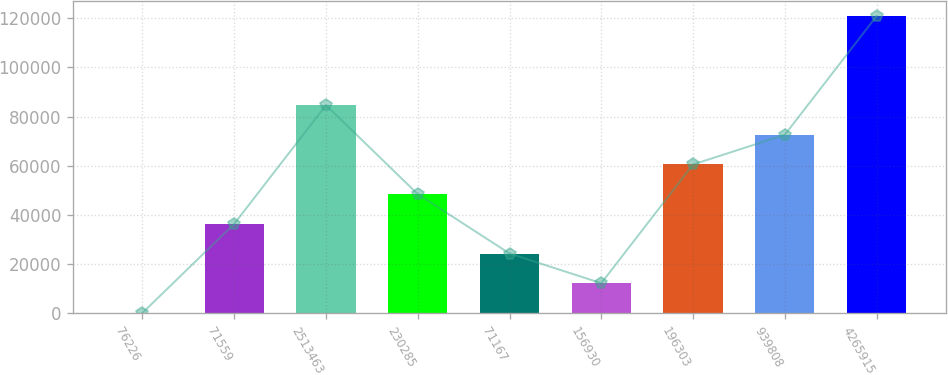<chart> <loc_0><loc_0><loc_500><loc_500><bar_chart><fcel>76226<fcel>71559<fcel>2513463<fcel>230285<fcel>71167<fcel>156930<fcel>196303<fcel>939808<fcel>4265915<nl><fcel>158<fcel>36362<fcel>84634<fcel>48430<fcel>24294<fcel>12226<fcel>60498<fcel>72566<fcel>120838<nl></chart> 